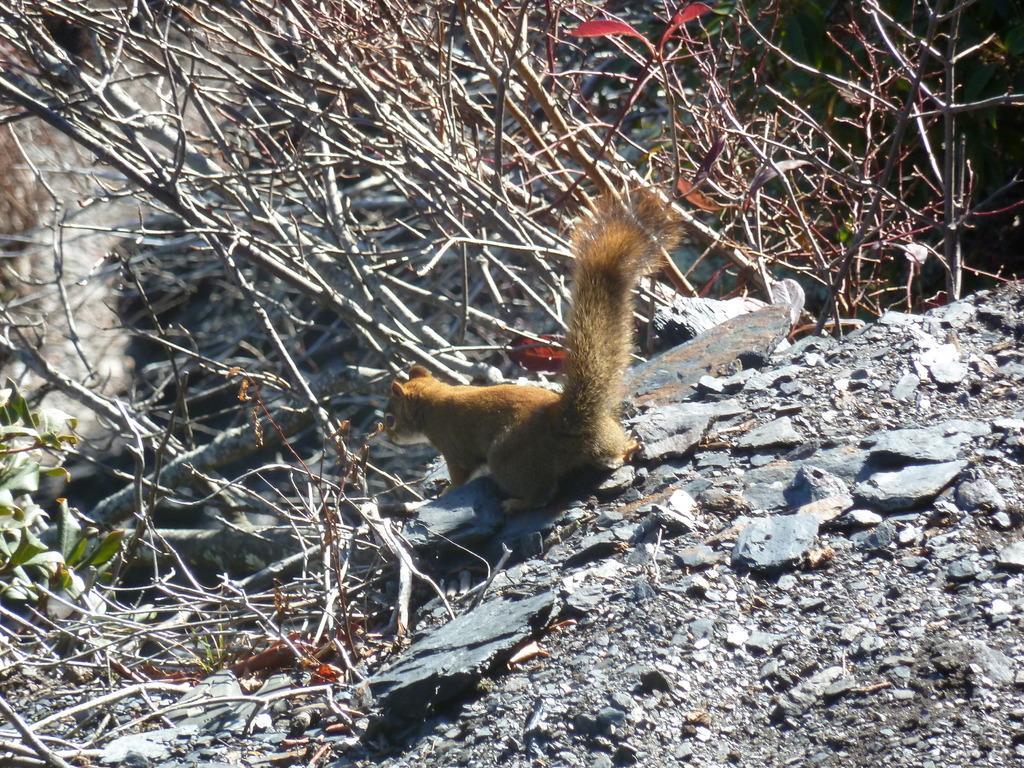Describe this image in one or two sentences. This picture is clicked outside. In the center there is a squirrel seems to be standing on the ground and we can see the gravels, dry stems and some green leaves. 